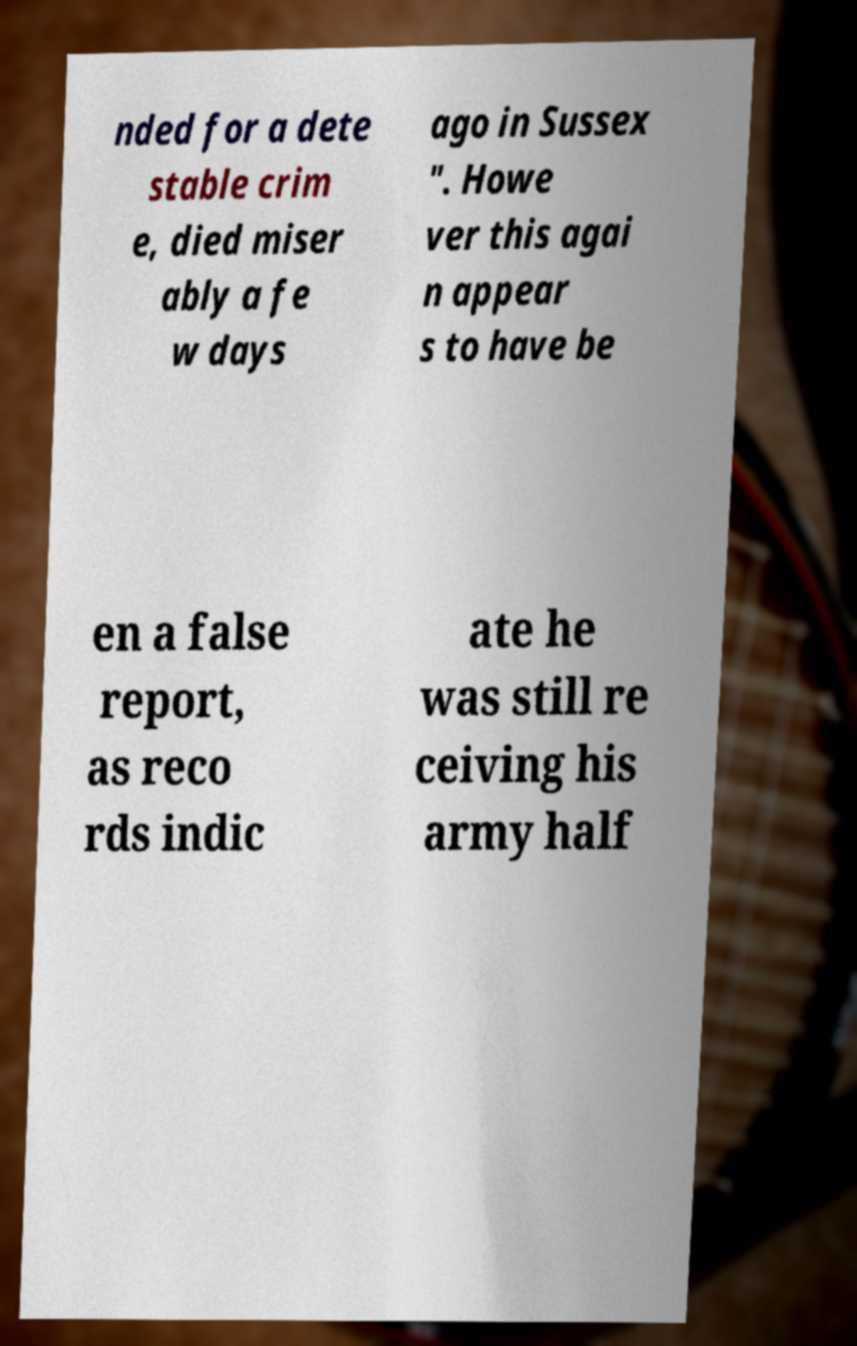Could you assist in decoding the text presented in this image and type it out clearly? nded for a dete stable crim e, died miser ably a fe w days ago in Sussex ". Howe ver this agai n appear s to have be en a false report, as reco rds indic ate he was still re ceiving his army half 